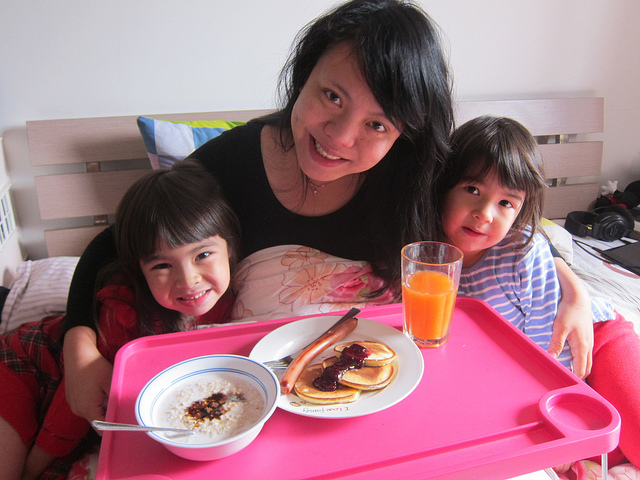What meal are they sharing, and what does this imply about the time of day? They are sharing a breakfast meal, indicated by typical morning foods such as pancakes and oatmeal. Given the choice of food and the bright natural light coming from outside, it implies that this scene occurs in the morning. Is there anything in the image that indicates a special occasion? There are no obvious indicators of a special occasion such as decorations or gifts. The meal seems like a regular family breakfast; however, capturing the moment with a photo might hint at the family's appreciation for everyday moments together. 